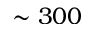<formula> <loc_0><loc_0><loc_500><loc_500>\sim 3 0 0</formula> 